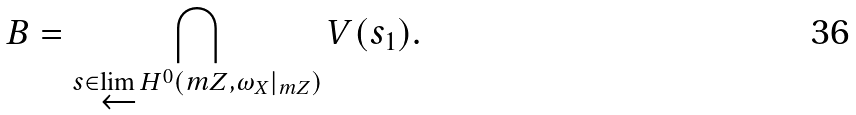Convert formula to latex. <formula><loc_0><loc_0><loc_500><loc_500>B = \bigcap _ { s \in \varprojlim H ^ { 0 } ( m Z , \omega _ { X } | _ { m Z } ) } V ( s _ { 1 } ) .</formula> 